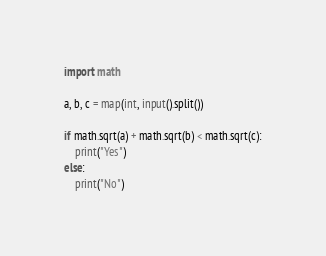<code> <loc_0><loc_0><loc_500><loc_500><_Python_>import math

a, b, c = map(int, input().split())

if math.sqrt(a) + math.sqrt(b) < math.sqrt(c):
    print("Yes")
else:
    print("No")
</code> 